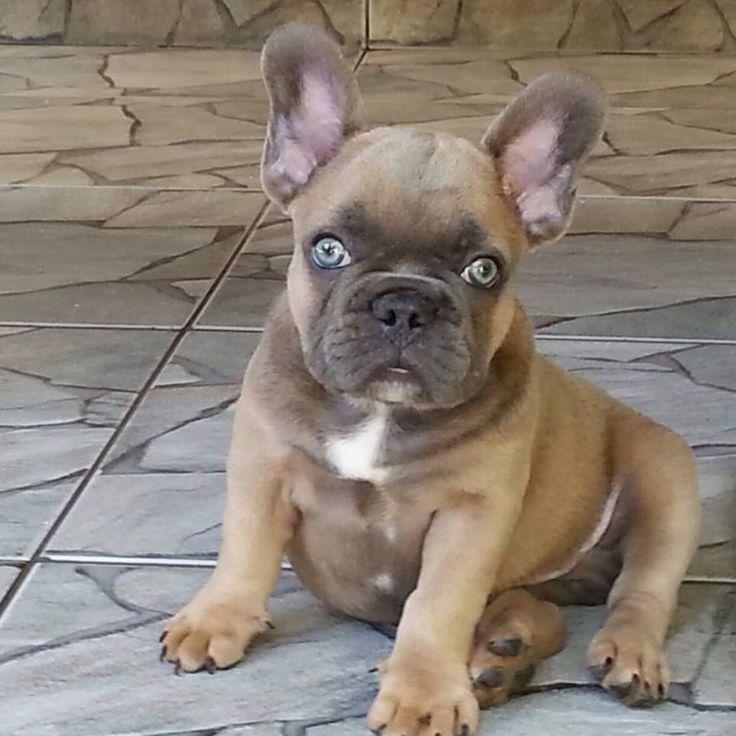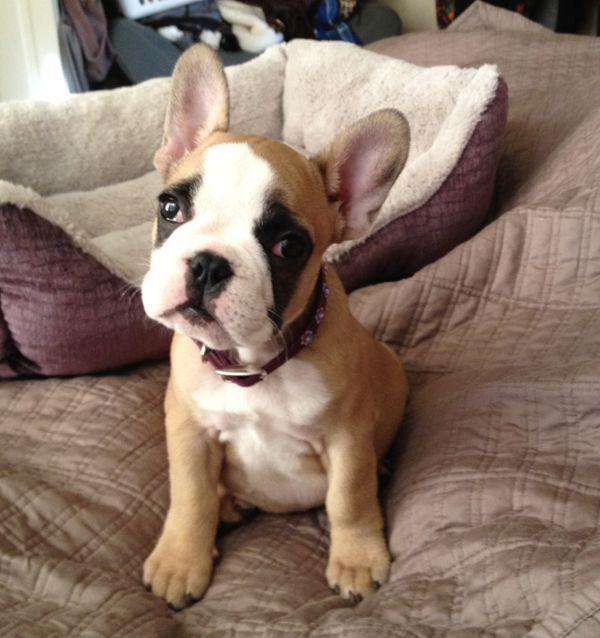The first image is the image on the left, the second image is the image on the right. Evaluate the accuracy of this statement regarding the images: "One of the images features a dog that is wearing a collar.". Is it true? Answer yes or no. Yes. The first image is the image on the left, the second image is the image on the right. Evaluate the accuracy of this statement regarding the images: "Each image contains a single dog, which is gazing toward the front and has its mouth closed.". Is it true? Answer yes or no. Yes. 